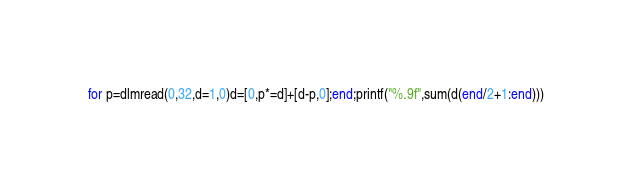<code> <loc_0><loc_0><loc_500><loc_500><_Octave_>for p=dlmread(0,32,d=1,0)d=[0,p*=d]+[d-p,0];end;printf("%.9f",sum(d(end/2+1:end)))</code> 